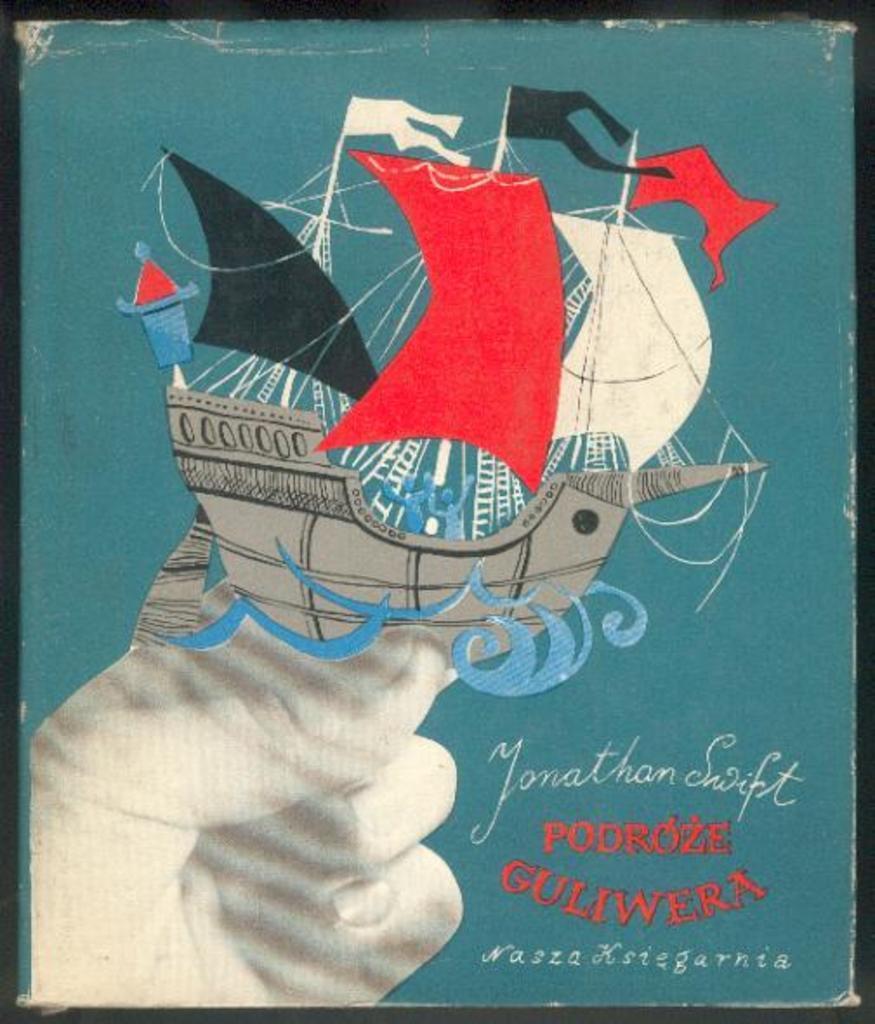Please provide a concise description of this image. In this image we can see painting of hand, ship and some written text on it. 